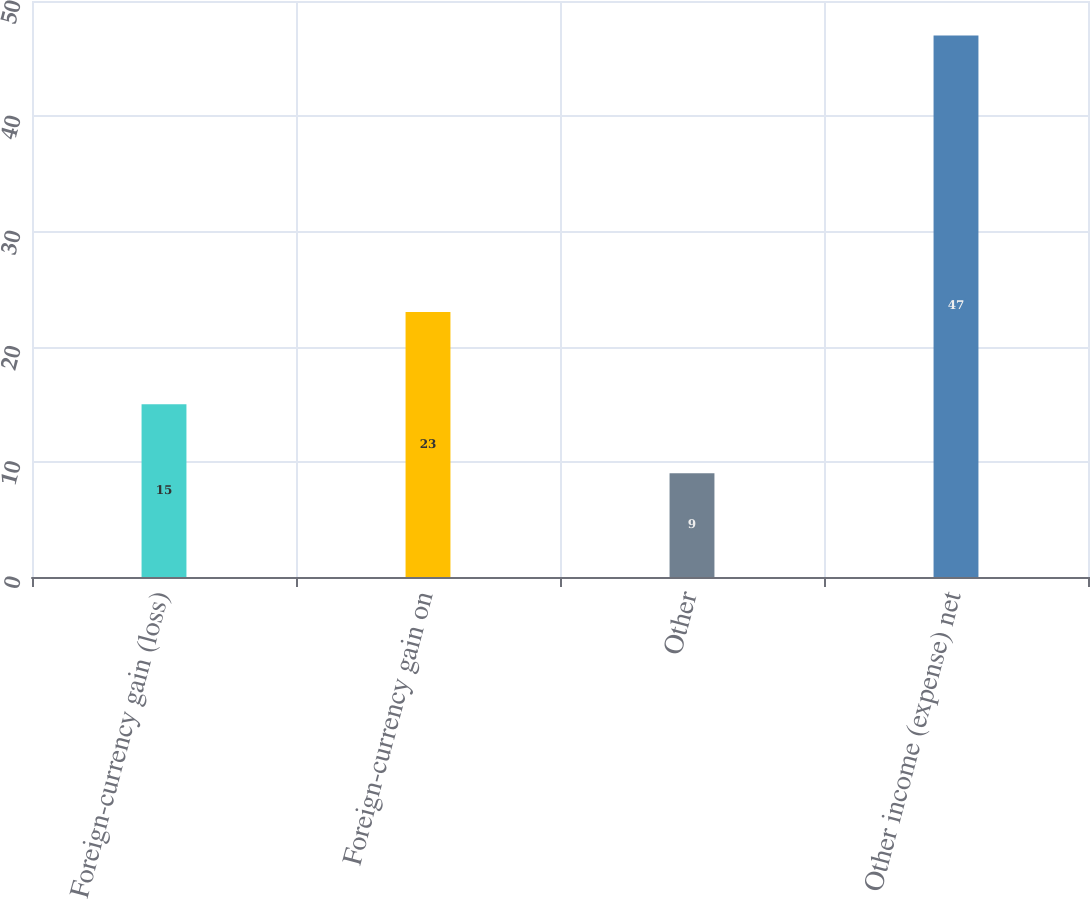Convert chart. <chart><loc_0><loc_0><loc_500><loc_500><bar_chart><fcel>Foreign-currency gain (loss)<fcel>Foreign-currency gain on<fcel>Other<fcel>Other income (expense) net<nl><fcel>15<fcel>23<fcel>9<fcel>47<nl></chart> 